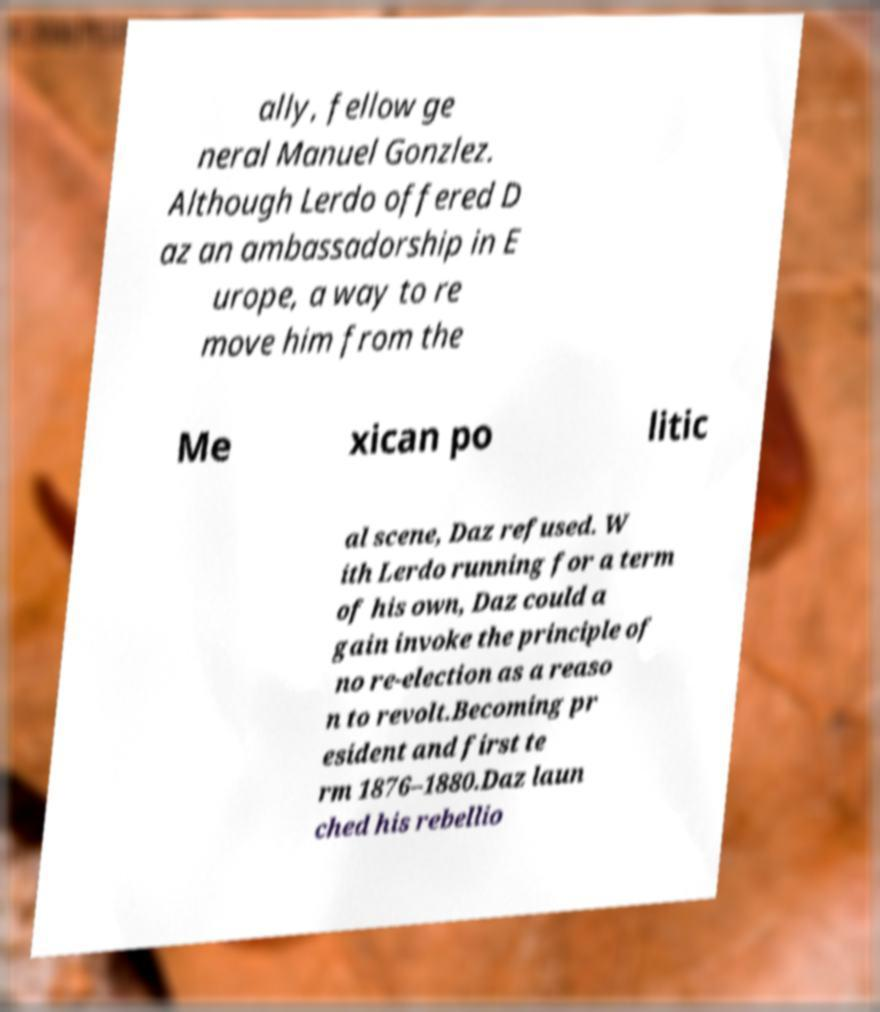What messages or text are displayed in this image? I need them in a readable, typed format. ally, fellow ge neral Manuel Gonzlez. Although Lerdo offered D az an ambassadorship in E urope, a way to re move him from the Me xican po litic al scene, Daz refused. W ith Lerdo running for a term of his own, Daz could a gain invoke the principle of no re-election as a reaso n to revolt.Becoming pr esident and first te rm 1876–1880.Daz laun ched his rebellio 